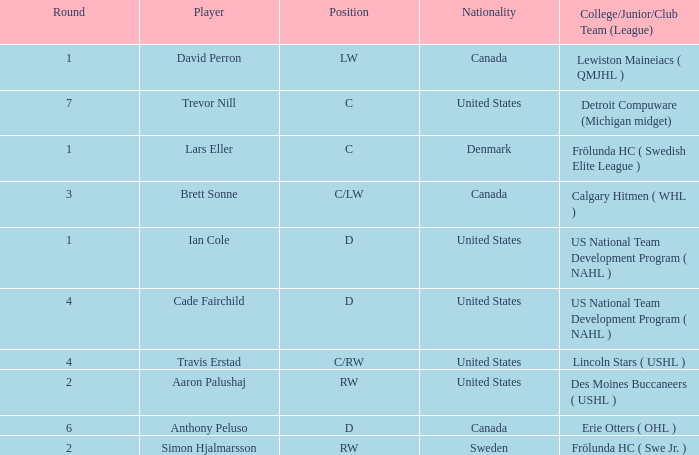Who is the player from Denmark who plays position c? Lars Eller. 